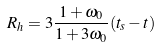<formula> <loc_0><loc_0><loc_500><loc_500>R _ { h } = 3 \frac { 1 + \omega _ { 0 } } { 1 + 3 \omega _ { 0 } } ( t _ { s } - t )</formula> 